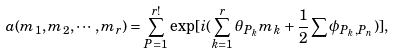Convert formula to latex. <formula><loc_0><loc_0><loc_500><loc_500>a ( m _ { 1 } , m _ { 2 } , \cdots , m _ { r } ) = \sum _ { P = 1 } ^ { r ! } \exp [ i ( \sum _ { k = 1 } ^ { r } { \theta _ { P _ { k } } } m _ { k } + \frac { 1 } { 2 } \sum \phi _ { P _ { k } , P _ { n } } ) ] ,</formula> 